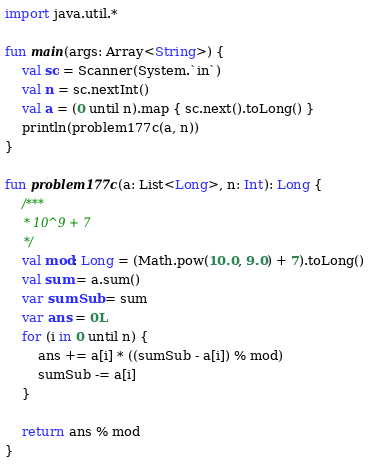<code> <loc_0><loc_0><loc_500><loc_500><_Kotlin_>import java.util.*

fun main(args: Array<String>) {
    val sc = Scanner(System.`in`)
    val n = sc.nextInt()
    val a = (0 until n).map { sc.next().toLong() }
    println(problem177c(a, n))
}

fun problem177c(a: List<Long>, n: Int): Long {
    /***
     * 10^9 + 7
     */
    val mod: Long = (Math.pow(10.0, 9.0) + 7).toLong()
    val sum = a.sum()
    var sumSub = sum
    var ans = 0L
    for (i in 0 until n) {
        ans += a[i] * ((sumSub - a[i]) % mod)
        sumSub -= a[i]
    }

    return ans % mod
}</code> 